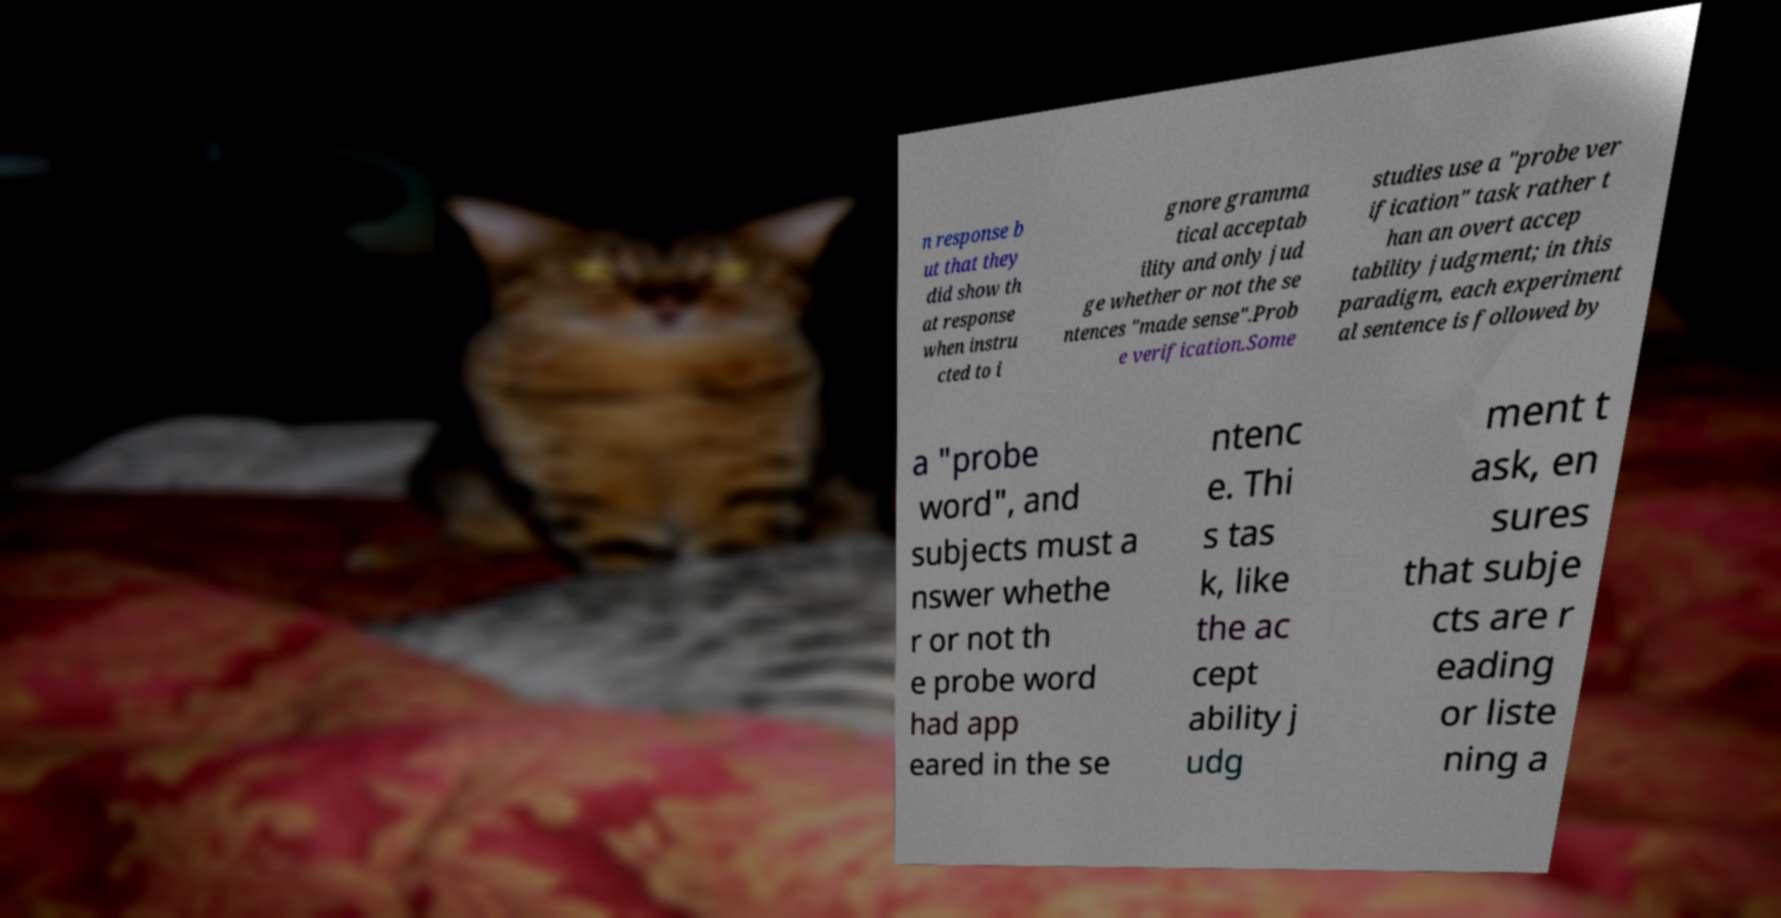Can you read and provide the text displayed in the image?This photo seems to have some interesting text. Can you extract and type it out for me? n response b ut that they did show th at response when instru cted to i gnore gramma tical acceptab ility and only jud ge whether or not the se ntences "made sense".Prob e verification.Some studies use a "probe ver ification" task rather t han an overt accep tability judgment; in this paradigm, each experiment al sentence is followed by a "probe word", and subjects must a nswer whethe r or not th e probe word had app eared in the se ntenc e. Thi s tas k, like the ac cept ability j udg ment t ask, en sures that subje cts are r eading or liste ning a 